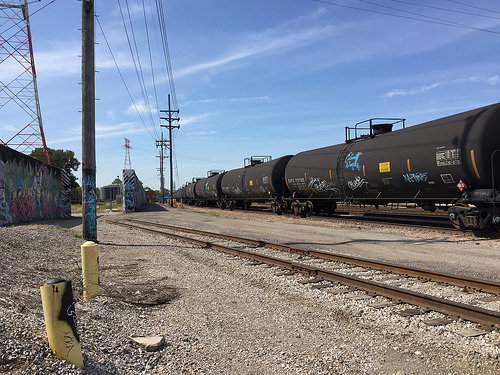<image>
Is there a train on the rail? No. The train is not positioned on the rail. They may be near each other, but the train is not supported by or resting on top of the rail. 